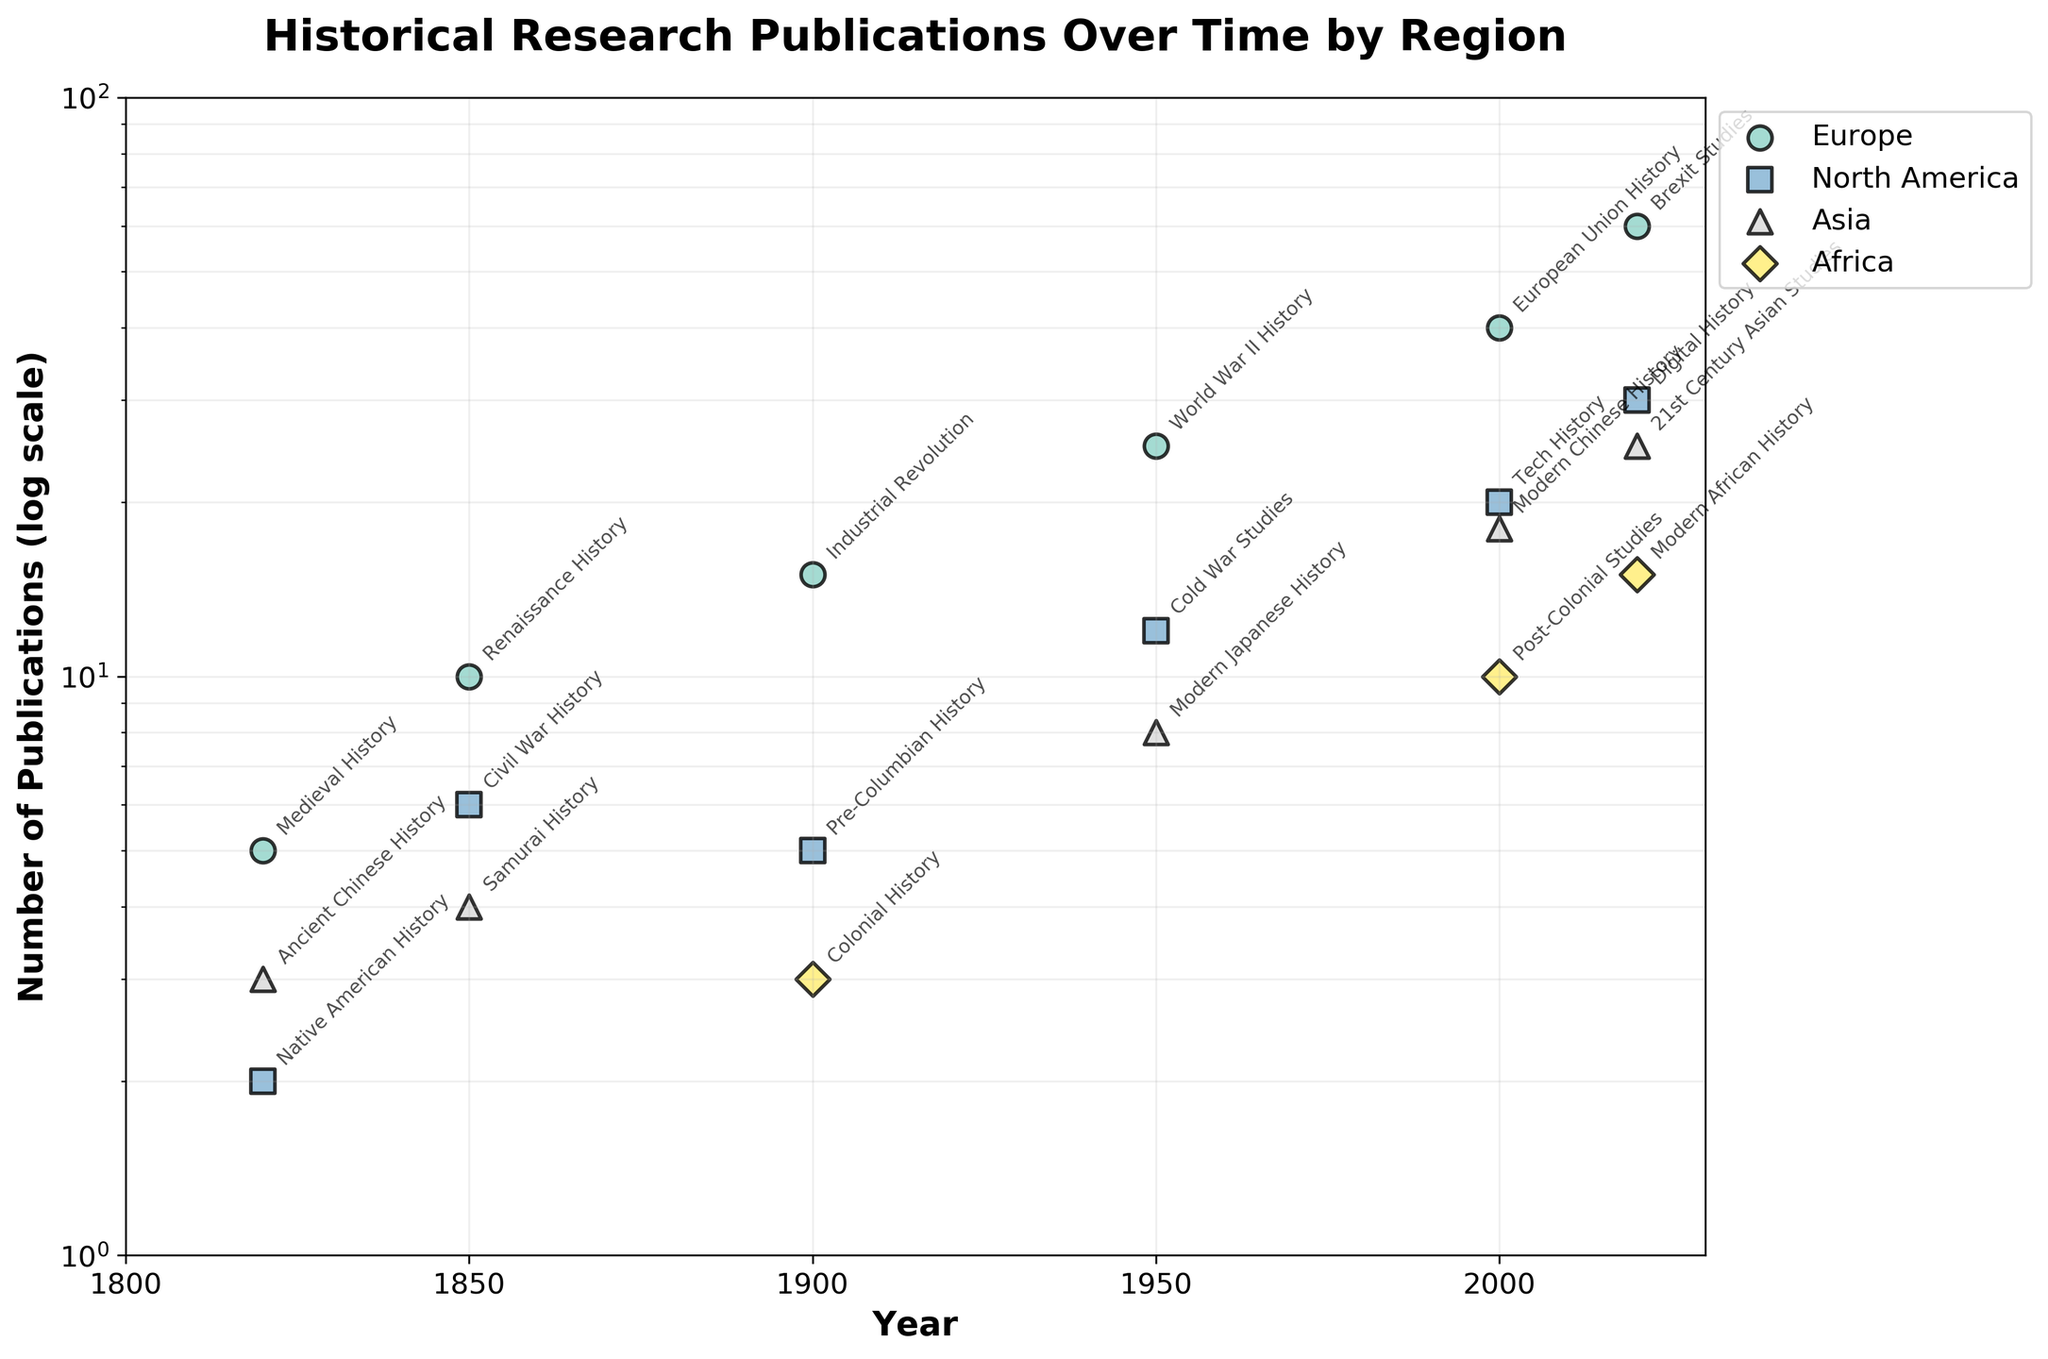What does the y-axis represent in the plot? The y-axis represents the Number of Publications and is plotted on a log scale, which means that the scale increases exponentially.
Answer: Number of Publications (log scale) How many historical research papers were published in North America on Digital History in 2020? In 2020, North America's publication count for Digital History is marked, and it shows 30 publications.
Answer: 30 Which region had the highest increase in the number of publications from 1820 to 2020? Comparing the number of publications in 1820 and 2020, Europe shows a significant increase from 5 (Medieval History) to 60 (Brexit Studies).
Answer: Europe What is the trend in the number of publications in Europe between 1820 and 2020? The trend in Europe shows a continuous increase: 5 in 1820, 10 in 1850, 15 in 1900, 25 in 1950, 40 in 2000, and 60 in 2020.
Answer: Increasing Which topic in Asia had the highest number of publications in the year 2000? Observing data for 2000, Modern Chinese History in Asia had 18 publications, which is the highest among the listed topics in Asia.
Answer: Modern Chinese History How does the number of publications in Africa in 2000 compare to Asia in the same year? In 2000, Africa had 10 publications (Post-Colonial Studies) while Asia had 18 publications (Modern Chinese History), so Africa had fewer publications compared to Asia.
Answer: Fewer What is the range of publication counts for topics in Europe in 2020? In 2020, Europe had 60 publications for Brexit Studies, and this is the only value mentioned for Europe in that year, so the range is single-valued.
Answer: 60 Which year saw the highest number of publications in Europe, and what was the topic? 2020 had the highest number of publications in Europe with 60 publications, and the topic was Brexit Studies.
Answer: 2020, Brexit Studies How do publications on Tech History in North America in 2000 compare to Colonial History in Africa in 1900? In 2000, North America had 20 publications on Tech History, whereas in 1900, Africa had 3 publications on Colonial History. Thus, North America had more publications.
Answer: More 